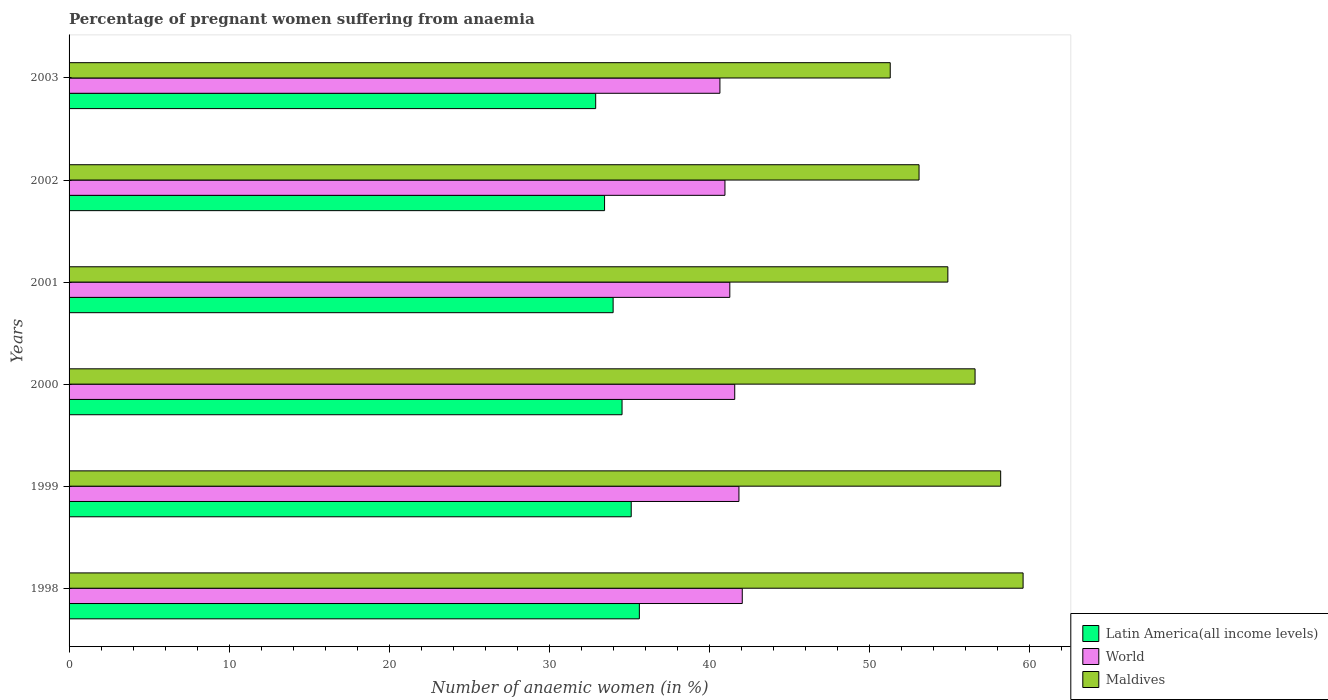How many different coloured bars are there?
Offer a terse response. 3. How many groups of bars are there?
Provide a succinct answer. 6. What is the label of the 4th group of bars from the top?
Ensure brevity in your answer.  2000. What is the number of anaemic women in Latin America(all income levels) in 2001?
Your answer should be compact. 33.99. Across all years, what is the maximum number of anaemic women in Latin America(all income levels)?
Provide a short and direct response. 35.63. Across all years, what is the minimum number of anaemic women in Latin America(all income levels)?
Make the answer very short. 32.9. What is the total number of anaemic women in World in the graph?
Provide a succinct answer. 248.4. What is the difference between the number of anaemic women in Maldives in 1999 and that in 2002?
Keep it short and to the point. 5.1. What is the difference between the number of anaemic women in World in 2000 and the number of anaemic women in Maldives in 1999?
Your answer should be compact. -16.61. What is the average number of anaemic women in World per year?
Provide a succinct answer. 41.4. In the year 2000, what is the difference between the number of anaemic women in World and number of anaemic women in Maldives?
Your answer should be very brief. -15.01. In how many years, is the number of anaemic women in Latin America(all income levels) greater than 44 %?
Your answer should be compact. 0. What is the ratio of the number of anaemic women in World in 1998 to that in 2000?
Keep it short and to the point. 1.01. What is the difference between the highest and the second highest number of anaemic women in Latin America(all income levels)?
Your answer should be compact. 0.51. What is the difference between the highest and the lowest number of anaemic women in Latin America(all income levels)?
Your answer should be very brief. 2.73. In how many years, is the number of anaemic women in Latin America(all income levels) greater than the average number of anaemic women in Latin America(all income levels) taken over all years?
Offer a terse response. 3. Is the sum of the number of anaemic women in World in 1999 and 2001 greater than the maximum number of anaemic women in Maldives across all years?
Provide a succinct answer. Yes. What does the 1st bar from the top in 1999 represents?
Provide a short and direct response. Maldives. What does the 2nd bar from the bottom in 2003 represents?
Your response must be concise. World. Is it the case that in every year, the sum of the number of anaemic women in Maldives and number of anaemic women in World is greater than the number of anaemic women in Latin America(all income levels)?
Provide a succinct answer. Yes. How many bars are there?
Offer a very short reply. 18. Are all the bars in the graph horizontal?
Your answer should be very brief. Yes. What is the difference between two consecutive major ticks on the X-axis?
Your answer should be very brief. 10. Are the values on the major ticks of X-axis written in scientific E-notation?
Make the answer very short. No. How many legend labels are there?
Your response must be concise. 3. How are the legend labels stacked?
Your answer should be very brief. Vertical. What is the title of the graph?
Your response must be concise. Percentage of pregnant women suffering from anaemia. Does "South Sudan" appear as one of the legend labels in the graph?
Make the answer very short. No. What is the label or title of the X-axis?
Your response must be concise. Number of anaemic women (in %). What is the Number of anaemic women (in %) in Latin America(all income levels) in 1998?
Give a very brief answer. 35.63. What is the Number of anaemic women (in %) in World in 1998?
Offer a very short reply. 42.06. What is the Number of anaemic women (in %) in Maldives in 1998?
Keep it short and to the point. 59.6. What is the Number of anaemic women (in %) in Latin America(all income levels) in 1999?
Ensure brevity in your answer.  35.12. What is the Number of anaemic women (in %) of World in 1999?
Keep it short and to the point. 41.85. What is the Number of anaemic women (in %) in Maldives in 1999?
Ensure brevity in your answer.  58.2. What is the Number of anaemic women (in %) in Latin America(all income levels) in 2000?
Your response must be concise. 34.55. What is the Number of anaemic women (in %) of World in 2000?
Provide a succinct answer. 41.59. What is the Number of anaemic women (in %) in Maldives in 2000?
Your answer should be very brief. 56.6. What is the Number of anaemic women (in %) in Latin America(all income levels) in 2001?
Give a very brief answer. 33.99. What is the Number of anaemic women (in %) of World in 2001?
Your answer should be compact. 41.28. What is the Number of anaemic women (in %) of Maldives in 2001?
Provide a succinct answer. 54.9. What is the Number of anaemic women (in %) in Latin America(all income levels) in 2002?
Your answer should be compact. 33.45. What is the Number of anaemic women (in %) of World in 2002?
Ensure brevity in your answer.  40.97. What is the Number of anaemic women (in %) in Maldives in 2002?
Ensure brevity in your answer.  53.1. What is the Number of anaemic women (in %) in Latin America(all income levels) in 2003?
Your answer should be compact. 32.9. What is the Number of anaemic women (in %) of World in 2003?
Give a very brief answer. 40.66. What is the Number of anaemic women (in %) in Maldives in 2003?
Provide a short and direct response. 51.3. Across all years, what is the maximum Number of anaemic women (in %) in Latin America(all income levels)?
Your answer should be compact. 35.63. Across all years, what is the maximum Number of anaemic women (in %) in World?
Ensure brevity in your answer.  42.06. Across all years, what is the maximum Number of anaemic women (in %) in Maldives?
Your answer should be compact. 59.6. Across all years, what is the minimum Number of anaemic women (in %) of Latin America(all income levels)?
Provide a succinct answer. 32.9. Across all years, what is the minimum Number of anaemic women (in %) in World?
Provide a succinct answer. 40.66. Across all years, what is the minimum Number of anaemic women (in %) of Maldives?
Provide a succinct answer. 51.3. What is the total Number of anaemic women (in %) of Latin America(all income levels) in the graph?
Offer a terse response. 205.63. What is the total Number of anaemic women (in %) in World in the graph?
Provide a succinct answer. 248.4. What is the total Number of anaemic women (in %) of Maldives in the graph?
Provide a succinct answer. 333.7. What is the difference between the Number of anaemic women (in %) in Latin America(all income levels) in 1998 and that in 1999?
Ensure brevity in your answer.  0.51. What is the difference between the Number of anaemic women (in %) in World in 1998 and that in 1999?
Offer a very short reply. 0.21. What is the difference between the Number of anaemic women (in %) in Maldives in 1998 and that in 1999?
Offer a very short reply. 1.4. What is the difference between the Number of anaemic women (in %) of Latin America(all income levels) in 1998 and that in 2000?
Your response must be concise. 1.08. What is the difference between the Number of anaemic women (in %) in World in 1998 and that in 2000?
Provide a short and direct response. 0.47. What is the difference between the Number of anaemic women (in %) of Maldives in 1998 and that in 2000?
Ensure brevity in your answer.  3. What is the difference between the Number of anaemic women (in %) in Latin America(all income levels) in 1998 and that in 2001?
Your answer should be compact. 1.64. What is the difference between the Number of anaemic women (in %) in World in 1998 and that in 2001?
Provide a succinct answer. 0.78. What is the difference between the Number of anaemic women (in %) of Latin America(all income levels) in 1998 and that in 2002?
Your response must be concise. 2.17. What is the difference between the Number of anaemic women (in %) in World in 1998 and that in 2002?
Your answer should be compact. 1.08. What is the difference between the Number of anaemic women (in %) in Latin America(all income levels) in 1998 and that in 2003?
Ensure brevity in your answer.  2.73. What is the difference between the Number of anaemic women (in %) in World in 1998 and that in 2003?
Provide a succinct answer. 1.4. What is the difference between the Number of anaemic women (in %) in Maldives in 1998 and that in 2003?
Provide a short and direct response. 8.3. What is the difference between the Number of anaemic women (in %) in Latin America(all income levels) in 1999 and that in 2000?
Keep it short and to the point. 0.57. What is the difference between the Number of anaemic women (in %) of World in 1999 and that in 2000?
Give a very brief answer. 0.26. What is the difference between the Number of anaemic women (in %) in Maldives in 1999 and that in 2000?
Your response must be concise. 1.6. What is the difference between the Number of anaemic women (in %) in Latin America(all income levels) in 1999 and that in 2001?
Your response must be concise. 1.13. What is the difference between the Number of anaemic women (in %) of World in 1999 and that in 2001?
Offer a terse response. 0.57. What is the difference between the Number of anaemic women (in %) of Latin America(all income levels) in 1999 and that in 2002?
Your answer should be very brief. 1.67. What is the difference between the Number of anaemic women (in %) of World in 1999 and that in 2002?
Make the answer very short. 0.87. What is the difference between the Number of anaemic women (in %) of Latin America(all income levels) in 1999 and that in 2003?
Give a very brief answer. 2.22. What is the difference between the Number of anaemic women (in %) in World in 1999 and that in 2003?
Offer a very short reply. 1.19. What is the difference between the Number of anaemic women (in %) of Latin America(all income levels) in 2000 and that in 2001?
Your answer should be compact. 0.56. What is the difference between the Number of anaemic women (in %) of World in 2000 and that in 2001?
Offer a very short reply. 0.31. What is the difference between the Number of anaemic women (in %) in Latin America(all income levels) in 2000 and that in 2002?
Make the answer very short. 1.09. What is the difference between the Number of anaemic women (in %) in World in 2000 and that in 2002?
Keep it short and to the point. 0.61. What is the difference between the Number of anaemic women (in %) in Latin America(all income levels) in 2000 and that in 2003?
Offer a terse response. 1.65. What is the difference between the Number of anaemic women (in %) of World in 2000 and that in 2003?
Ensure brevity in your answer.  0.93. What is the difference between the Number of anaemic women (in %) in Latin America(all income levels) in 2001 and that in 2002?
Your answer should be compact. 0.53. What is the difference between the Number of anaemic women (in %) in World in 2001 and that in 2002?
Your answer should be compact. 0.3. What is the difference between the Number of anaemic women (in %) of Latin America(all income levels) in 2001 and that in 2003?
Offer a terse response. 1.09. What is the difference between the Number of anaemic women (in %) of World in 2001 and that in 2003?
Provide a short and direct response. 0.62. What is the difference between the Number of anaemic women (in %) of Maldives in 2001 and that in 2003?
Offer a very short reply. 3.6. What is the difference between the Number of anaemic women (in %) of Latin America(all income levels) in 2002 and that in 2003?
Give a very brief answer. 0.55. What is the difference between the Number of anaemic women (in %) of World in 2002 and that in 2003?
Make the answer very short. 0.31. What is the difference between the Number of anaemic women (in %) of Maldives in 2002 and that in 2003?
Your answer should be very brief. 1.8. What is the difference between the Number of anaemic women (in %) in Latin America(all income levels) in 1998 and the Number of anaemic women (in %) in World in 1999?
Make the answer very short. -6.22. What is the difference between the Number of anaemic women (in %) in Latin America(all income levels) in 1998 and the Number of anaemic women (in %) in Maldives in 1999?
Your answer should be very brief. -22.57. What is the difference between the Number of anaemic women (in %) in World in 1998 and the Number of anaemic women (in %) in Maldives in 1999?
Keep it short and to the point. -16.14. What is the difference between the Number of anaemic women (in %) in Latin America(all income levels) in 1998 and the Number of anaemic women (in %) in World in 2000?
Ensure brevity in your answer.  -5.96. What is the difference between the Number of anaemic women (in %) of Latin America(all income levels) in 1998 and the Number of anaemic women (in %) of Maldives in 2000?
Make the answer very short. -20.97. What is the difference between the Number of anaemic women (in %) in World in 1998 and the Number of anaemic women (in %) in Maldives in 2000?
Offer a very short reply. -14.54. What is the difference between the Number of anaemic women (in %) in Latin America(all income levels) in 1998 and the Number of anaemic women (in %) in World in 2001?
Your answer should be compact. -5.65. What is the difference between the Number of anaemic women (in %) of Latin America(all income levels) in 1998 and the Number of anaemic women (in %) of Maldives in 2001?
Your answer should be very brief. -19.27. What is the difference between the Number of anaemic women (in %) in World in 1998 and the Number of anaemic women (in %) in Maldives in 2001?
Give a very brief answer. -12.84. What is the difference between the Number of anaemic women (in %) of Latin America(all income levels) in 1998 and the Number of anaemic women (in %) of World in 2002?
Offer a very short reply. -5.35. What is the difference between the Number of anaemic women (in %) in Latin America(all income levels) in 1998 and the Number of anaemic women (in %) in Maldives in 2002?
Your response must be concise. -17.47. What is the difference between the Number of anaemic women (in %) of World in 1998 and the Number of anaemic women (in %) of Maldives in 2002?
Offer a terse response. -11.04. What is the difference between the Number of anaemic women (in %) in Latin America(all income levels) in 1998 and the Number of anaemic women (in %) in World in 2003?
Offer a very short reply. -5.03. What is the difference between the Number of anaemic women (in %) in Latin America(all income levels) in 1998 and the Number of anaemic women (in %) in Maldives in 2003?
Your response must be concise. -15.67. What is the difference between the Number of anaemic women (in %) in World in 1998 and the Number of anaemic women (in %) in Maldives in 2003?
Your answer should be very brief. -9.24. What is the difference between the Number of anaemic women (in %) in Latin America(all income levels) in 1999 and the Number of anaemic women (in %) in World in 2000?
Provide a succinct answer. -6.47. What is the difference between the Number of anaemic women (in %) of Latin America(all income levels) in 1999 and the Number of anaemic women (in %) of Maldives in 2000?
Ensure brevity in your answer.  -21.48. What is the difference between the Number of anaemic women (in %) of World in 1999 and the Number of anaemic women (in %) of Maldives in 2000?
Your answer should be compact. -14.75. What is the difference between the Number of anaemic women (in %) in Latin America(all income levels) in 1999 and the Number of anaemic women (in %) in World in 2001?
Offer a very short reply. -6.16. What is the difference between the Number of anaemic women (in %) in Latin America(all income levels) in 1999 and the Number of anaemic women (in %) in Maldives in 2001?
Keep it short and to the point. -19.78. What is the difference between the Number of anaemic women (in %) of World in 1999 and the Number of anaemic women (in %) of Maldives in 2001?
Make the answer very short. -13.05. What is the difference between the Number of anaemic women (in %) of Latin America(all income levels) in 1999 and the Number of anaemic women (in %) of World in 2002?
Ensure brevity in your answer.  -5.86. What is the difference between the Number of anaemic women (in %) in Latin America(all income levels) in 1999 and the Number of anaemic women (in %) in Maldives in 2002?
Make the answer very short. -17.98. What is the difference between the Number of anaemic women (in %) of World in 1999 and the Number of anaemic women (in %) of Maldives in 2002?
Offer a very short reply. -11.25. What is the difference between the Number of anaemic women (in %) in Latin America(all income levels) in 1999 and the Number of anaemic women (in %) in World in 2003?
Keep it short and to the point. -5.54. What is the difference between the Number of anaemic women (in %) of Latin America(all income levels) in 1999 and the Number of anaemic women (in %) of Maldives in 2003?
Keep it short and to the point. -16.18. What is the difference between the Number of anaemic women (in %) of World in 1999 and the Number of anaemic women (in %) of Maldives in 2003?
Your answer should be compact. -9.45. What is the difference between the Number of anaemic women (in %) of Latin America(all income levels) in 2000 and the Number of anaemic women (in %) of World in 2001?
Provide a succinct answer. -6.73. What is the difference between the Number of anaemic women (in %) in Latin America(all income levels) in 2000 and the Number of anaemic women (in %) in Maldives in 2001?
Your answer should be compact. -20.35. What is the difference between the Number of anaemic women (in %) of World in 2000 and the Number of anaemic women (in %) of Maldives in 2001?
Your answer should be very brief. -13.31. What is the difference between the Number of anaemic women (in %) of Latin America(all income levels) in 2000 and the Number of anaemic women (in %) of World in 2002?
Your answer should be compact. -6.43. What is the difference between the Number of anaemic women (in %) of Latin America(all income levels) in 2000 and the Number of anaemic women (in %) of Maldives in 2002?
Provide a succinct answer. -18.55. What is the difference between the Number of anaemic women (in %) of World in 2000 and the Number of anaemic women (in %) of Maldives in 2002?
Your response must be concise. -11.51. What is the difference between the Number of anaemic women (in %) in Latin America(all income levels) in 2000 and the Number of anaemic women (in %) in World in 2003?
Ensure brevity in your answer.  -6.11. What is the difference between the Number of anaemic women (in %) in Latin America(all income levels) in 2000 and the Number of anaemic women (in %) in Maldives in 2003?
Your response must be concise. -16.75. What is the difference between the Number of anaemic women (in %) of World in 2000 and the Number of anaemic women (in %) of Maldives in 2003?
Give a very brief answer. -9.71. What is the difference between the Number of anaemic women (in %) of Latin America(all income levels) in 2001 and the Number of anaemic women (in %) of World in 2002?
Your answer should be compact. -6.99. What is the difference between the Number of anaemic women (in %) in Latin America(all income levels) in 2001 and the Number of anaemic women (in %) in Maldives in 2002?
Your answer should be compact. -19.11. What is the difference between the Number of anaemic women (in %) of World in 2001 and the Number of anaemic women (in %) of Maldives in 2002?
Your response must be concise. -11.82. What is the difference between the Number of anaemic women (in %) of Latin America(all income levels) in 2001 and the Number of anaemic women (in %) of World in 2003?
Offer a terse response. -6.67. What is the difference between the Number of anaemic women (in %) in Latin America(all income levels) in 2001 and the Number of anaemic women (in %) in Maldives in 2003?
Offer a terse response. -17.31. What is the difference between the Number of anaemic women (in %) in World in 2001 and the Number of anaemic women (in %) in Maldives in 2003?
Make the answer very short. -10.02. What is the difference between the Number of anaemic women (in %) of Latin America(all income levels) in 2002 and the Number of anaemic women (in %) of World in 2003?
Keep it short and to the point. -7.21. What is the difference between the Number of anaemic women (in %) of Latin America(all income levels) in 2002 and the Number of anaemic women (in %) of Maldives in 2003?
Provide a succinct answer. -17.85. What is the difference between the Number of anaemic women (in %) of World in 2002 and the Number of anaemic women (in %) of Maldives in 2003?
Offer a terse response. -10.33. What is the average Number of anaemic women (in %) of Latin America(all income levels) per year?
Give a very brief answer. 34.27. What is the average Number of anaemic women (in %) in World per year?
Provide a succinct answer. 41.4. What is the average Number of anaemic women (in %) in Maldives per year?
Your answer should be very brief. 55.62. In the year 1998, what is the difference between the Number of anaemic women (in %) of Latin America(all income levels) and Number of anaemic women (in %) of World?
Your answer should be very brief. -6.43. In the year 1998, what is the difference between the Number of anaemic women (in %) in Latin America(all income levels) and Number of anaemic women (in %) in Maldives?
Provide a short and direct response. -23.97. In the year 1998, what is the difference between the Number of anaemic women (in %) in World and Number of anaemic women (in %) in Maldives?
Give a very brief answer. -17.54. In the year 1999, what is the difference between the Number of anaemic women (in %) in Latin America(all income levels) and Number of anaemic women (in %) in World?
Provide a short and direct response. -6.73. In the year 1999, what is the difference between the Number of anaemic women (in %) in Latin America(all income levels) and Number of anaemic women (in %) in Maldives?
Offer a very short reply. -23.08. In the year 1999, what is the difference between the Number of anaemic women (in %) in World and Number of anaemic women (in %) in Maldives?
Your response must be concise. -16.35. In the year 2000, what is the difference between the Number of anaemic women (in %) of Latin America(all income levels) and Number of anaemic women (in %) of World?
Give a very brief answer. -7.04. In the year 2000, what is the difference between the Number of anaemic women (in %) in Latin America(all income levels) and Number of anaemic women (in %) in Maldives?
Your response must be concise. -22.05. In the year 2000, what is the difference between the Number of anaemic women (in %) of World and Number of anaemic women (in %) of Maldives?
Ensure brevity in your answer.  -15.01. In the year 2001, what is the difference between the Number of anaemic women (in %) of Latin America(all income levels) and Number of anaemic women (in %) of World?
Ensure brevity in your answer.  -7.29. In the year 2001, what is the difference between the Number of anaemic women (in %) in Latin America(all income levels) and Number of anaemic women (in %) in Maldives?
Offer a very short reply. -20.91. In the year 2001, what is the difference between the Number of anaemic women (in %) in World and Number of anaemic women (in %) in Maldives?
Offer a terse response. -13.62. In the year 2002, what is the difference between the Number of anaemic women (in %) of Latin America(all income levels) and Number of anaemic women (in %) of World?
Ensure brevity in your answer.  -7.52. In the year 2002, what is the difference between the Number of anaemic women (in %) of Latin America(all income levels) and Number of anaemic women (in %) of Maldives?
Provide a short and direct response. -19.65. In the year 2002, what is the difference between the Number of anaemic women (in %) of World and Number of anaemic women (in %) of Maldives?
Ensure brevity in your answer.  -12.13. In the year 2003, what is the difference between the Number of anaemic women (in %) of Latin America(all income levels) and Number of anaemic women (in %) of World?
Your answer should be very brief. -7.76. In the year 2003, what is the difference between the Number of anaemic women (in %) in Latin America(all income levels) and Number of anaemic women (in %) in Maldives?
Give a very brief answer. -18.4. In the year 2003, what is the difference between the Number of anaemic women (in %) in World and Number of anaemic women (in %) in Maldives?
Ensure brevity in your answer.  -10.64. What is the ratio of the Number of anaemic women (in %) of Latin America(all income levels) in 1998 to that in 1999?
Provide a succinct answer. 1.01. What is the ratio of the Number of anaemic women (in %) of Maldives in 1998 to that in 1999?
Provide a short and direct response. 1.02. What is the ratio of the Number of anaemic women (in %) in Latin America(all income levels) in 1998 to that in 2000?
Make the answer very short. 1.03. What is the ratio of the Number of anaemic women (in %) of World in 1998 to that in 2000?
Provide a succinct answer. 1.01. What is the ratio of the Number of anaemic women (in %) in Maldives in 1998 to that in 2000?
Provide a short and direct response. 1.05. What is the ratio of the Number of anaemic women (in %) in Latin America(all income levels) in 1998 to that in 2001?
Your response must be concise. 1.05. What is the ratio of the Number of anaemic women (in %) in World in 1998 to that in 2001?
Keep it short and to the point. 1.02. What is the ratio of the Number of anaemic women (in %) in Maldives in 1998 to that in 2001?
Make the answer very short. 1.09. What is the ratio of the Number of anaemic women (in %) of Latin America(all income levels) in 1998 to that in 2002?
Your answer should be compact. 1.06. What is the ratio of the Number of anaemic women (in %) of World in 1998 to that in 2002?
Offer a terse response. 1.03. What is the ratio of the Number of anaemic women (in %) in Maldives in 1998 to that in 2002?
Your answer should be very brief. 1.12. What is the ratio of the Number of anaemic women (in %) in Latin America(all income levels) in 1998 to that in 2003?
Make the answer very short. 1.08. What is the ratio of the Number of anaemic women (in %) of World in 1998 to that in 2003?
Offer a very short reply. 1.03. What is the ratio of the Number of anaemic women (in %) of Maldives in 1998 to that in 2003?
Your answer should be very brief. 1.16. What is the ratio of the Number of anaemic women (in %) of Latin America(all income levels) in 1999 to that in 2000?
Your answer should be compact. 1.02. What is the ratio of the Number of anaemic women (in %) in World in 1999 to that in 2000?
Offer a terse response. 1.01. What is the ratio of the Number of anaemic women (in %) in Maldives in 1999 to that in 2000?
Offer a terse response. 1.03. What is the ratio of the Number of anaemic women (in %) of Latin America(all income levels) in 1999 to that in 2001?
Provide a succinct answer. 1.03. What is the ratio of the Number of anaemic women (in %) in World in 1999 to that in 2001?
Give a very brief answer. 1.01. What is the ratio of the Number of anaemic women (in %) of Maldives in 1999 to that in 2001?
Offer a very short reply. 1.06. What is the ratio of the Number of anaemic women (in %) in Latin America(all income levels) in 1999 to that in 2002?
Offer a very short reply. 1.05. What is the ratio of the Number of anaemic women (in %) of World in 1999 to that in 2002?
Make the answer very short. 1.02. What is the ratio of the Number of anaemic women (in %) of Maldives in 1999 to that in 2002?
Offer a terse response. 1.1. What is the ratio of the Number of anaemic women (in %) in Latin America(all income levels) in 1999 to that in 2003?
Make the answer very short. 1.07. What is the ratio of the Number of anaemic women (in %) in World in 1999 to that in 2003?
Make the answer very short. 1.03. What is the ratio of the Number of anaemic women (in %) in Maldives in 1999 to that in 2003?
Ensure brevity in your answer.  1.13. What is the ratio of the Number of anaemic women (in %) of Latin America(all income levels) in 2000 to that in 2001?
Give a very brief answer. 1.02. What is the ratio of the Number of anaemic women (in %) in World in 2000 to that in 2001?
Keep it short and to the point. 1.01. What is the ratio of the Number of anaemic women (in %) in Maldives in 2000 to that in 2001?
Give a very brief answer. 1.03. What is the ratio of the Number of anaemic women (in %) of Latin America(all income levels) in 2000 to that in 2002?
Your answer should be compact. 1.03. What is the ratio of the Number of anaemic women (in %) in World in 2000 to that in 2002?
Make the answer very short. 1.01. What is the ratio of the Number of anaemic women (in %) of Maldives in 2000 to that in 2002?
Offer a very short reply. 1.07. What is the ratio of the Number of anaemic women (in %) in Latin America(all income levels) in 2000 to that in 2003?
Keep it short and to the point. 1.05. What is the ratio of the Number of anaemic women (in %) of World in 2000 to that in 2003?
Your answer should be compact. 1.02. What is the ratio of the Number of anaemic women (in %) of Maldives in 2000 to that in 2003?
Make the answer very short. 1.1. What is the ratio of the Number of anaemic women (in %) of World in 2001 to that in 2002?
Your answer should be very brief. 1.01. What is the ratio of the Number of anaemic women (in %) in Maldives in 2001 to that in 2002?
Provide a short and direct response. 1.03. What is the ratio of the Number of anaemic women (in %) in Latin America(all income levels) in 2001 to that in 2003?
Give a very brief answer. 1.03. What is the ratio of the Number of anaemic women (in %) of World in 2001 to that in 2003?
Ensure brevity in your answer.  1.02. What is the ratio of the Number of anaemic women (in %) of Maldives in 2001 to that in 2003?
Your response must be concise. 1.07. What is the ratio of the Number of anaemic women (in %) of Latin America(all income levels) in 2002 to that in 2003?
Offer a terse response. 1.02. What is the ratio of the Number of anaemic women (in %) of World in 2002 to that in 2003?
Give a very brief answer. 1.01. What is the ratio of the Number of anaemic women (in %) of Maldives in 2002 to that in 2003?
Keep it short and to the point. 1.04. What is the difference between the highest and the second highest Number of anaemic women (in %) in Latin America(all income levels)?
Offer a terse response. 0.51. What is the difference between the highest and the second highest Number of anaemic women (in %) in World?
Ensure brevity in your answer.  0.21. What is the difference between the highest and the second highest Number of anaemic women (in %) of Maldives?
Provide a short and direct response. 1.4. What is the difference between the highest and the lowest Number of anaemic women (in %) in Latin America(all income levels)?
Provide a succinct answer. 2.73. What is the difference between the highest and the lowest Number of anaemic women (in %) in World?
Your answer should be compact. 1.4. What is the difference between the highest and the lowest Number of anaemic women (in %) of Maldives?
Make the answer very short. 8.3. 